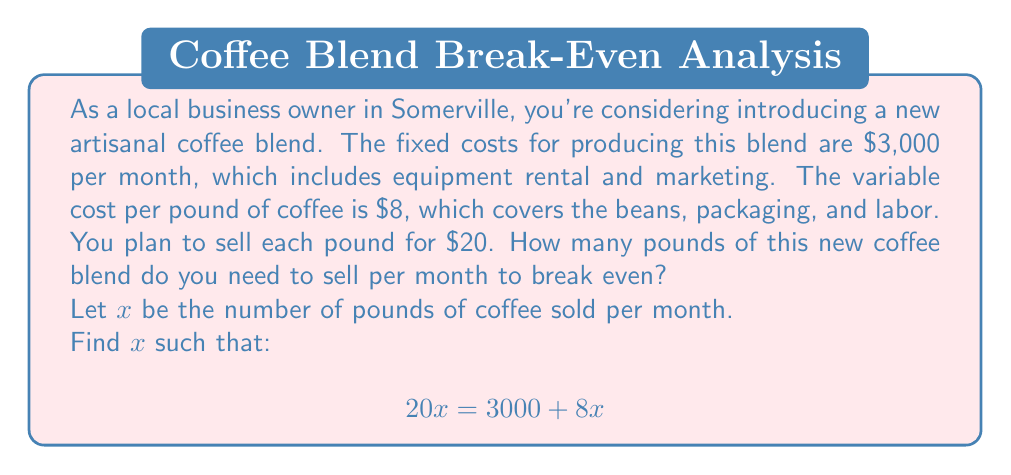Help me with this question. To determine the breakeven point, we need to find the point where total revenue equals total costs.

Let's define our variables:
$x$ = number of pounds of coffee sold
$P$ = price per pound = $20
$F$ = fixed costs = $3,000
$V$ = variable cost per pound = $8

The breakeven equation is:

Total Revenue = Total Costs
$$ Px = F + Vx $$

Substituting our values:

$$ 20x = 3000 + 8x $$

Now, let's solve for $x$:

1) Subtract $8x$ from both sides:
   $$ 20x - 8x = 3000 + 8x - 8x $$
   $$ 12x = 3000 $$

2) Divide both sides by 12:
   $$ x = \frac{3000}{12} = 250 $$

Therefore, you need to sell 250 pounds of coffee per month to break even.

To verify:
Revenue at 250 pounds: $20 * 250 = $5,000
Costs at 250 pounds: $3,000 + ($8 * 250) = $5,000

Indeed, at 250 pounds, revenue equals costs, confirming the breakeven point.
Answer: The breakeven point is 250 pounds of coffee per month. 